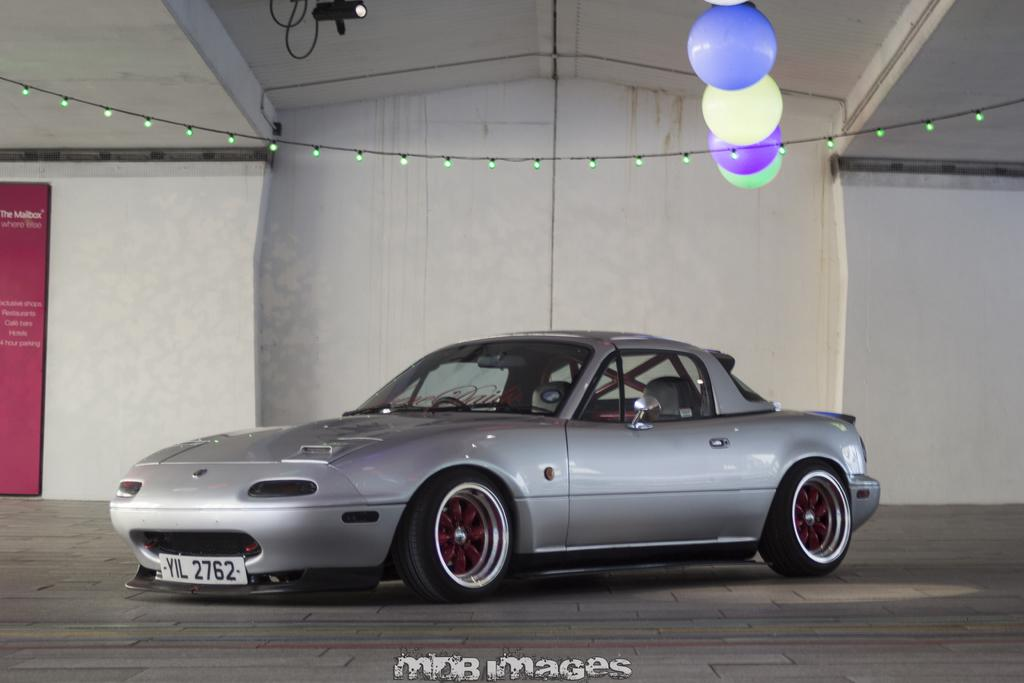What is the main subject of the image? There is a car in the image. What can be seen beneath the car? The ground is visible in the image. What is on the wall in the image? There is a wall with a poster on it. What can be seen illuminating the scene? There are lights in the image. What additional decorative elements are present? There are balloons in the image. What language is spoken by the balloons in the image? Balloons do not speak any language, as they are inanimate objects. 